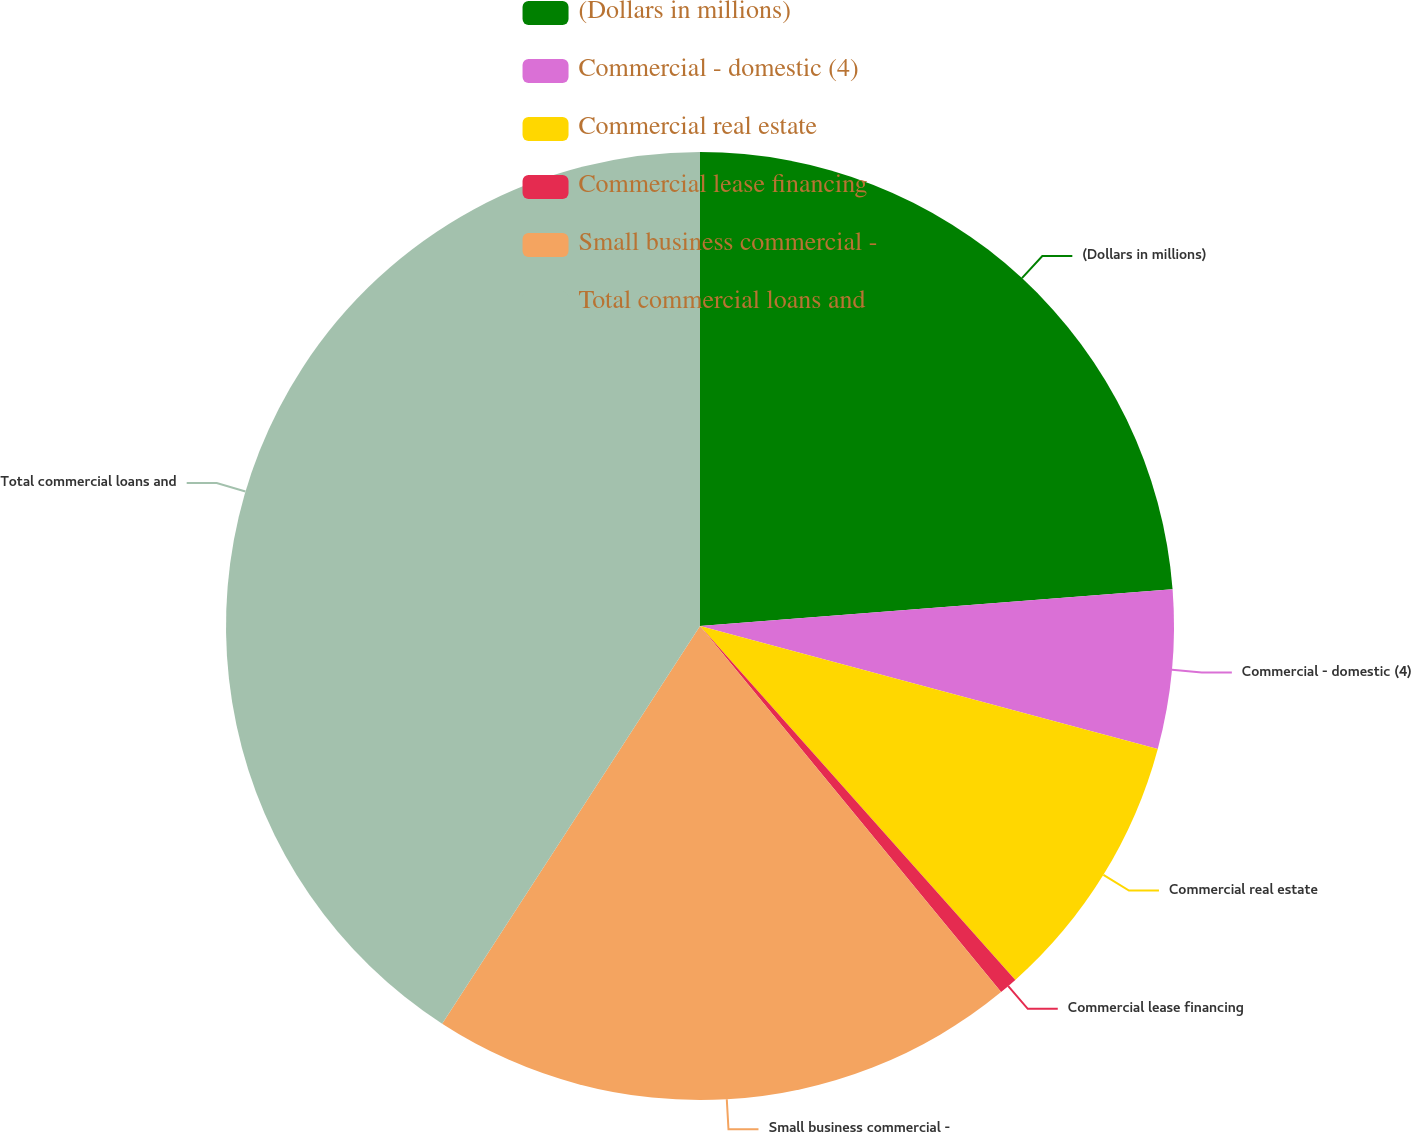Convert chart. <chart><loc_0><loc_0><loc_500><loc_500><pie_chart><fcel>(Dollars in millions)<fcel>Commercial - domestic (4)<fcel>Commercial real estate<fcel>Commercial lease financing<fcel>Small business commercial -<fcel>Total commercial loans and<nl><fcel>23.77%<fcel>5.41%<fcel>9.24%<fcel>0.63%<fcel>20.11%<fcel>40.85%<nl></chart> 